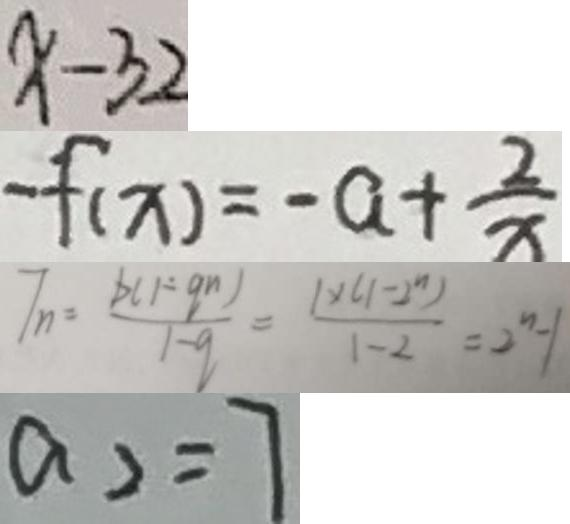Convert formula to latex. <formula><loc_0><loc_0><loc_500><loc_500>x - 3 2 
 - f ( x ) = - a + \frac { 2 } { x } 
 T _ { n } = \frac { b ( 1 - q ^ { n } ) } { 1 - q } = \frac { 1 \times ( 1 - 2 ^ { n } ) } { 1 - 2 } = 2 ^ { n } - 1 
 a _ { 2 } = 7</formula> 